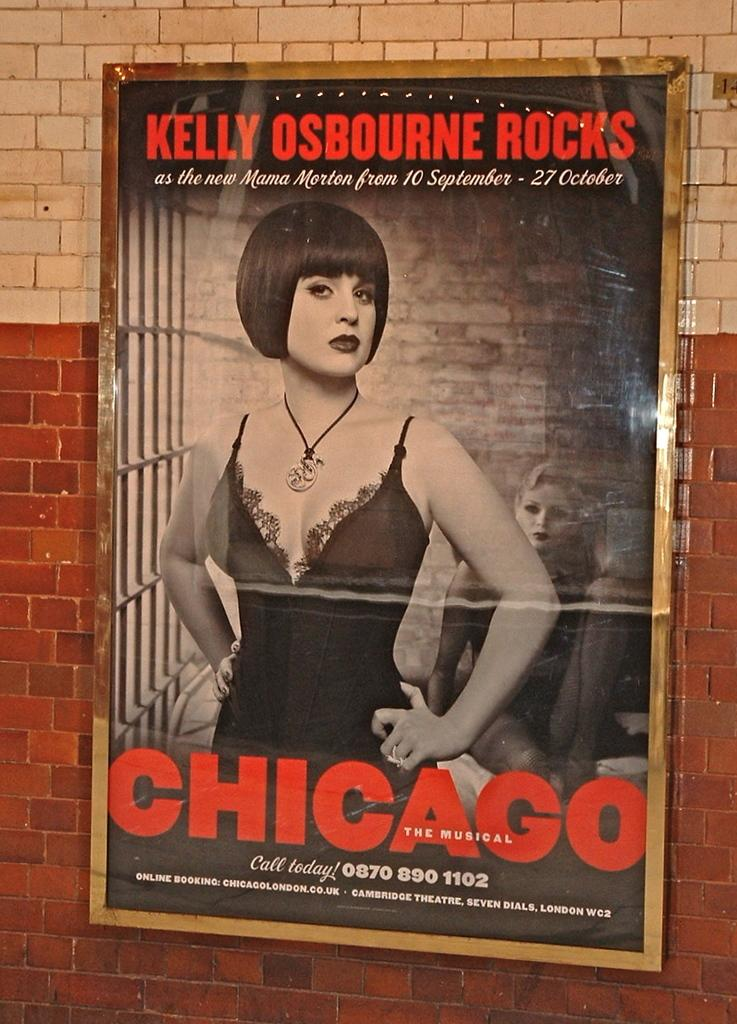<image>
Present a compact description of the photo's key features. A poster advertising the musical Chicago promoting Kelly Osbourne as one of the stars. 